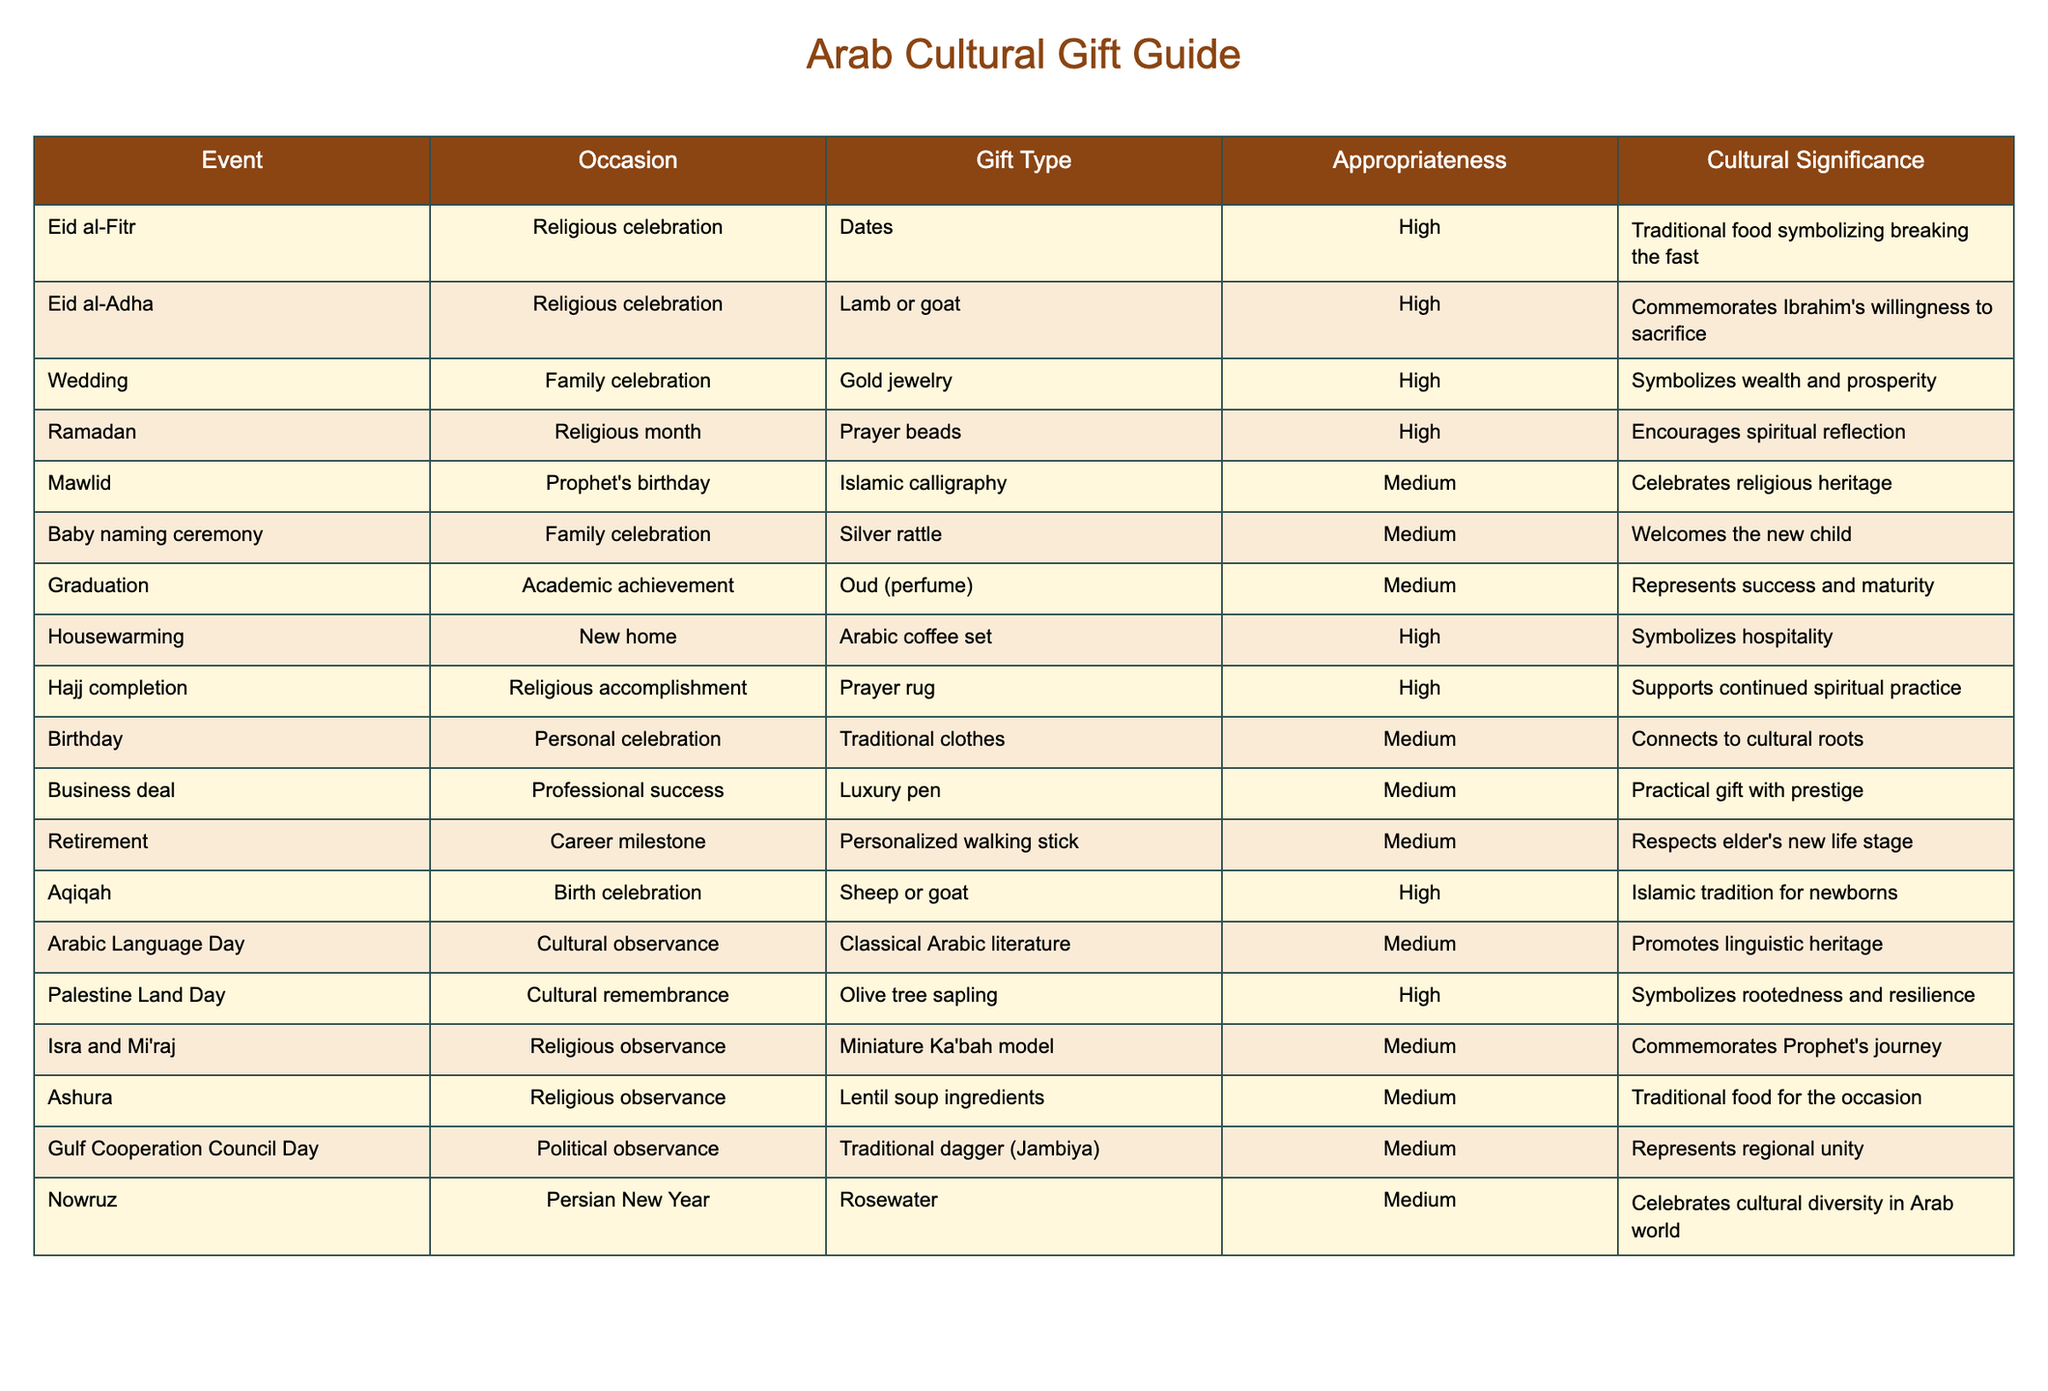What gift is considered highly appropriate for Eid al-Fitr? The table states that for Eid al-Fitr, the highly appropriate gift is Dates.
Answer: Dates Which occasion has the cultural significance of symbolizing wealth and prosperity? According to the table, the Wedding occasion is noted for having cultural significance that symbolizes wealth and prosperity, associated with the gift of Gold jewelry.
Answer: Wedding How many gifts listed are considered highly appropriate? The listed gifts with high appropriateness are: Dates (Eid al-Fitr), Lamb or goat (Eid al-Adha), Gold jewelry (Wedding), Arabic coffee set (Housewarming), Prayer rug (Hajj completion), and Sheep or goat (Aqiqah). Counting these gives a total of 6 gifts.
Answer: 6 Is it true that the gift for Baby naming ceremony holds a high appropriateness rating? The table indicates that the gift for the Baby naming ceremony, which is Silver rattle, has a medium appropriateness rating, not high. Therefore, the statement is false.
Answer: False Which gift represents success and maturity? The gift that represents success and maturity as per the table is Oud (perfume), given during the Graduation occasion.
Answer: Oud (perfume) What’s the combined total of occasions that are categorized as family celebrations? From the table, the family celebration occasions are Wedding, Baby naming ceremony, and Aqiqah which sums to a total of 3 distinct occasions.
Answer: 3 Which gift, associated with a cultural observance, promotes linguistic heritage? The table states that Classical Arabic literature is the gift associated with the cultural observance known as Arabic Language Day, which promotes linguistic heritage.
Answer: Classical Arabic literature Is it permissible to give a luxury pen during a cultural observance occasion? According to the table, Luxury pen is listed as a gift for a Business deal, which is a professional success, therefore it is not applicable for cultural observance occasions. The statement is false.
Answer: False Which occasion signifies rootedness and resilience through its associated gift? The gift for Palestine Land Day, which is an Olive tree sapling, signifies rootedness and resilience according to the cultural context provided in the table.
Answer: Olive tree sapling 